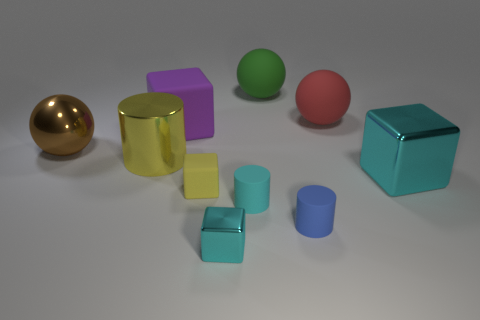Subtract all cylinders. How many objects are left? 7 Subtract all big gray metallic things. Subtract all blue cylinders. How many objects are left? 9 Add 2 small cyan metal cubes. How many small cyan metal cubes are left? 3 Add 6 cyan matte things. How many cyan matte things exist? 7 Subtract 1 purple blocks. How many objects are left? 9 